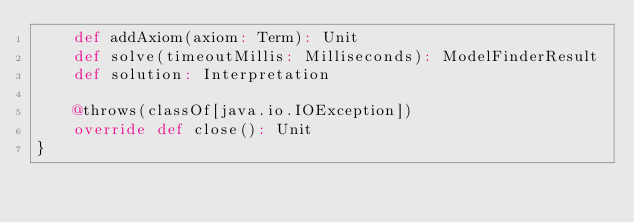<code> <loc_0><loc_0><loc_500><loc_500><_Scala_>    def addAxiom(axiom: Term): Unit
    def solve(timeoutMillis: Milliseconds): ModelFinderResult
    def solution: Interpretation
    
    @throws(classOf[java.io.IOException])
    override def close(): Unit
}
</code> 